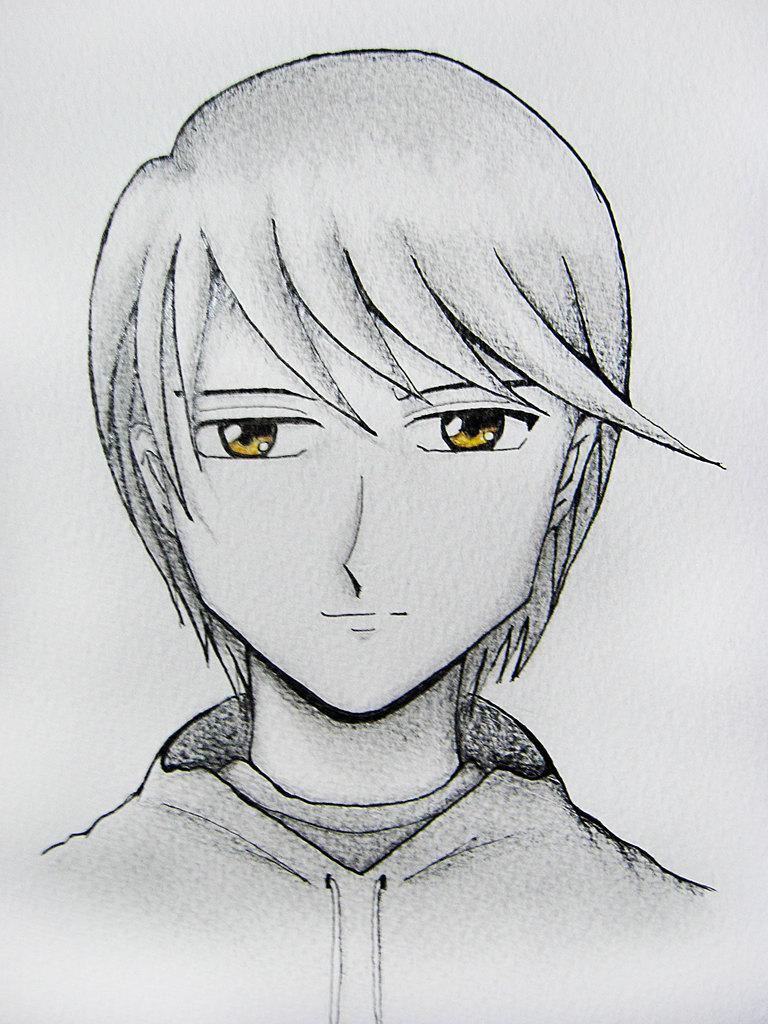What is depicted in the image? There is a sketch of a person in the image. What type of clover is the person sitting on in the image? There is no clover present in the image; it features a sketch of a person. What type of throne is the person sitting on in the image? There is no throne present in the image; it features a sketch of a person. 